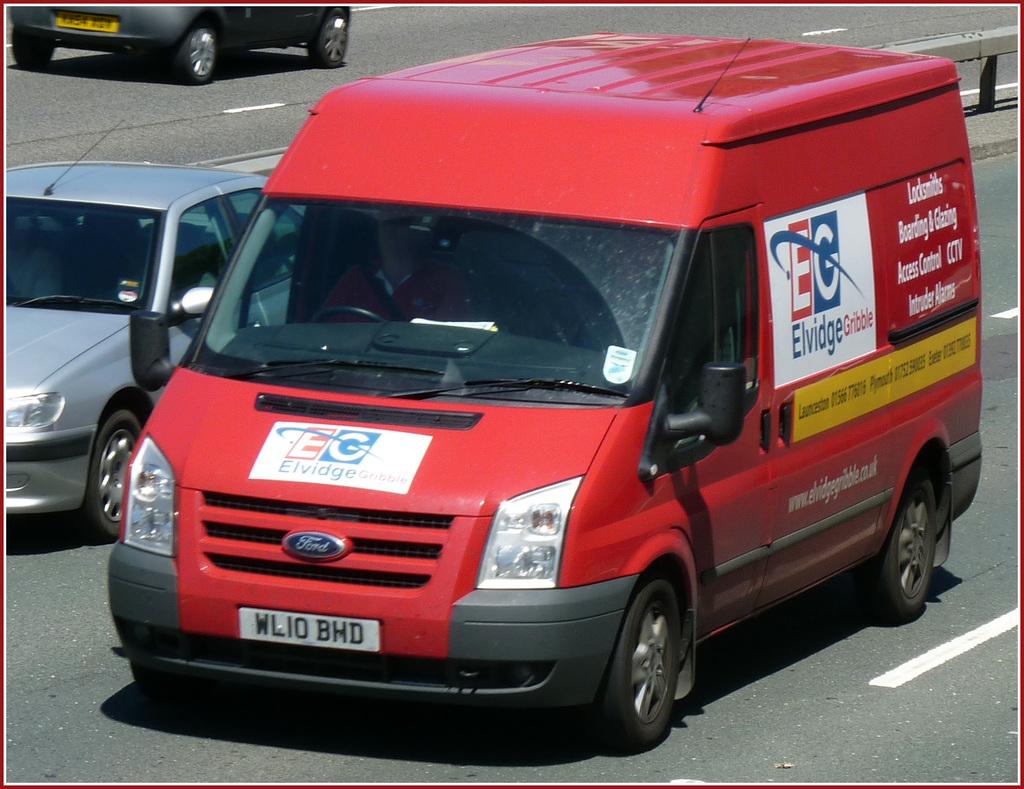What brand of van?
Offer a terse response. Ford. What is the company name on the van?
Offer a terse response. Elvidge gribble. 